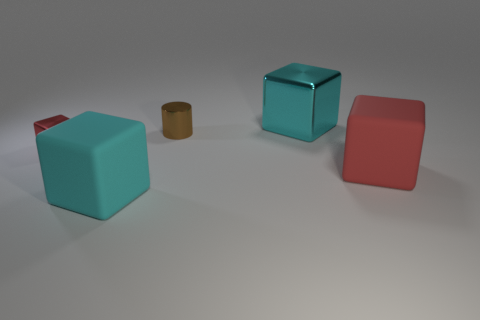Is there anything else of the same color as the tiny metal cube?
Keep it short and to the point. Yes. There is a small metallic cylinder; does it have the same color as the block right of the big cyan metallic thing?
Offer a very short reply. No. The tiny cylinder is what color?
Provide a succinct answer. Brown. Do the metallic object that is on the left side of the cyan matte object and the large metallic block have the same color?
Give a very brief answer. No. Is there another large metallic object of the same color as the big metallic object?
Provide a succinct answer. No. Do the big metallic cube and the tiny metallic block have the same color?
Offer a terse response. No. There is a thing that is the same color as the tiny shiny block; what shape is it?
Your answer should be compact. Cube. What is the size of the other cube that is the same color as the tiny metal block?
Your answer should be compact. Large. There is a tiny thing behind the thing that is to the left of the matte object that is on the left side of the brown object; what is its color?
Give a very brief answer. Brown. There is a thing that is both behind the big red rubber object and on the left side of the cylinder; what is its shape?
Provide a short and direct response. Cube. 